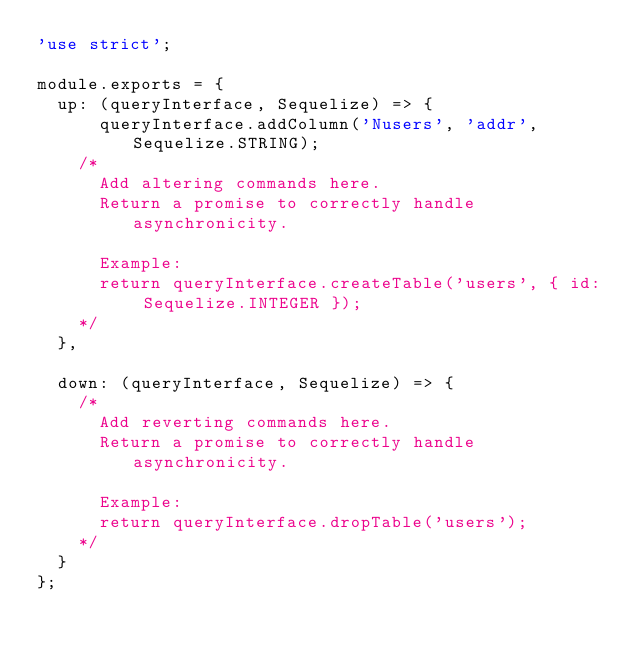Convert code to text. <code><loc_0><loc_0><loc_500><loc_500><_JavaScript_>'use strict';

module.exports = {
  up: (queryInterface, Sequelize) => {
	  queryInterface.addColumn('Nusers', 'addr', Sequelize.STRING);
    /*
      Add altering commands here.
      Return a promise to correctly handle asynchronicity.

      Example:
      return queryInterface.createTable('users', { id: Sequelize.INTEGER });
    */
  },

  down: (queryInterface, Sequelize) => {
    /*
      Add reverting commands here.
      Return a promise to correctly handle asynchronicity.

      Example:
      return queryInterface.dropTable('users');
    */
  }
};
</code> 